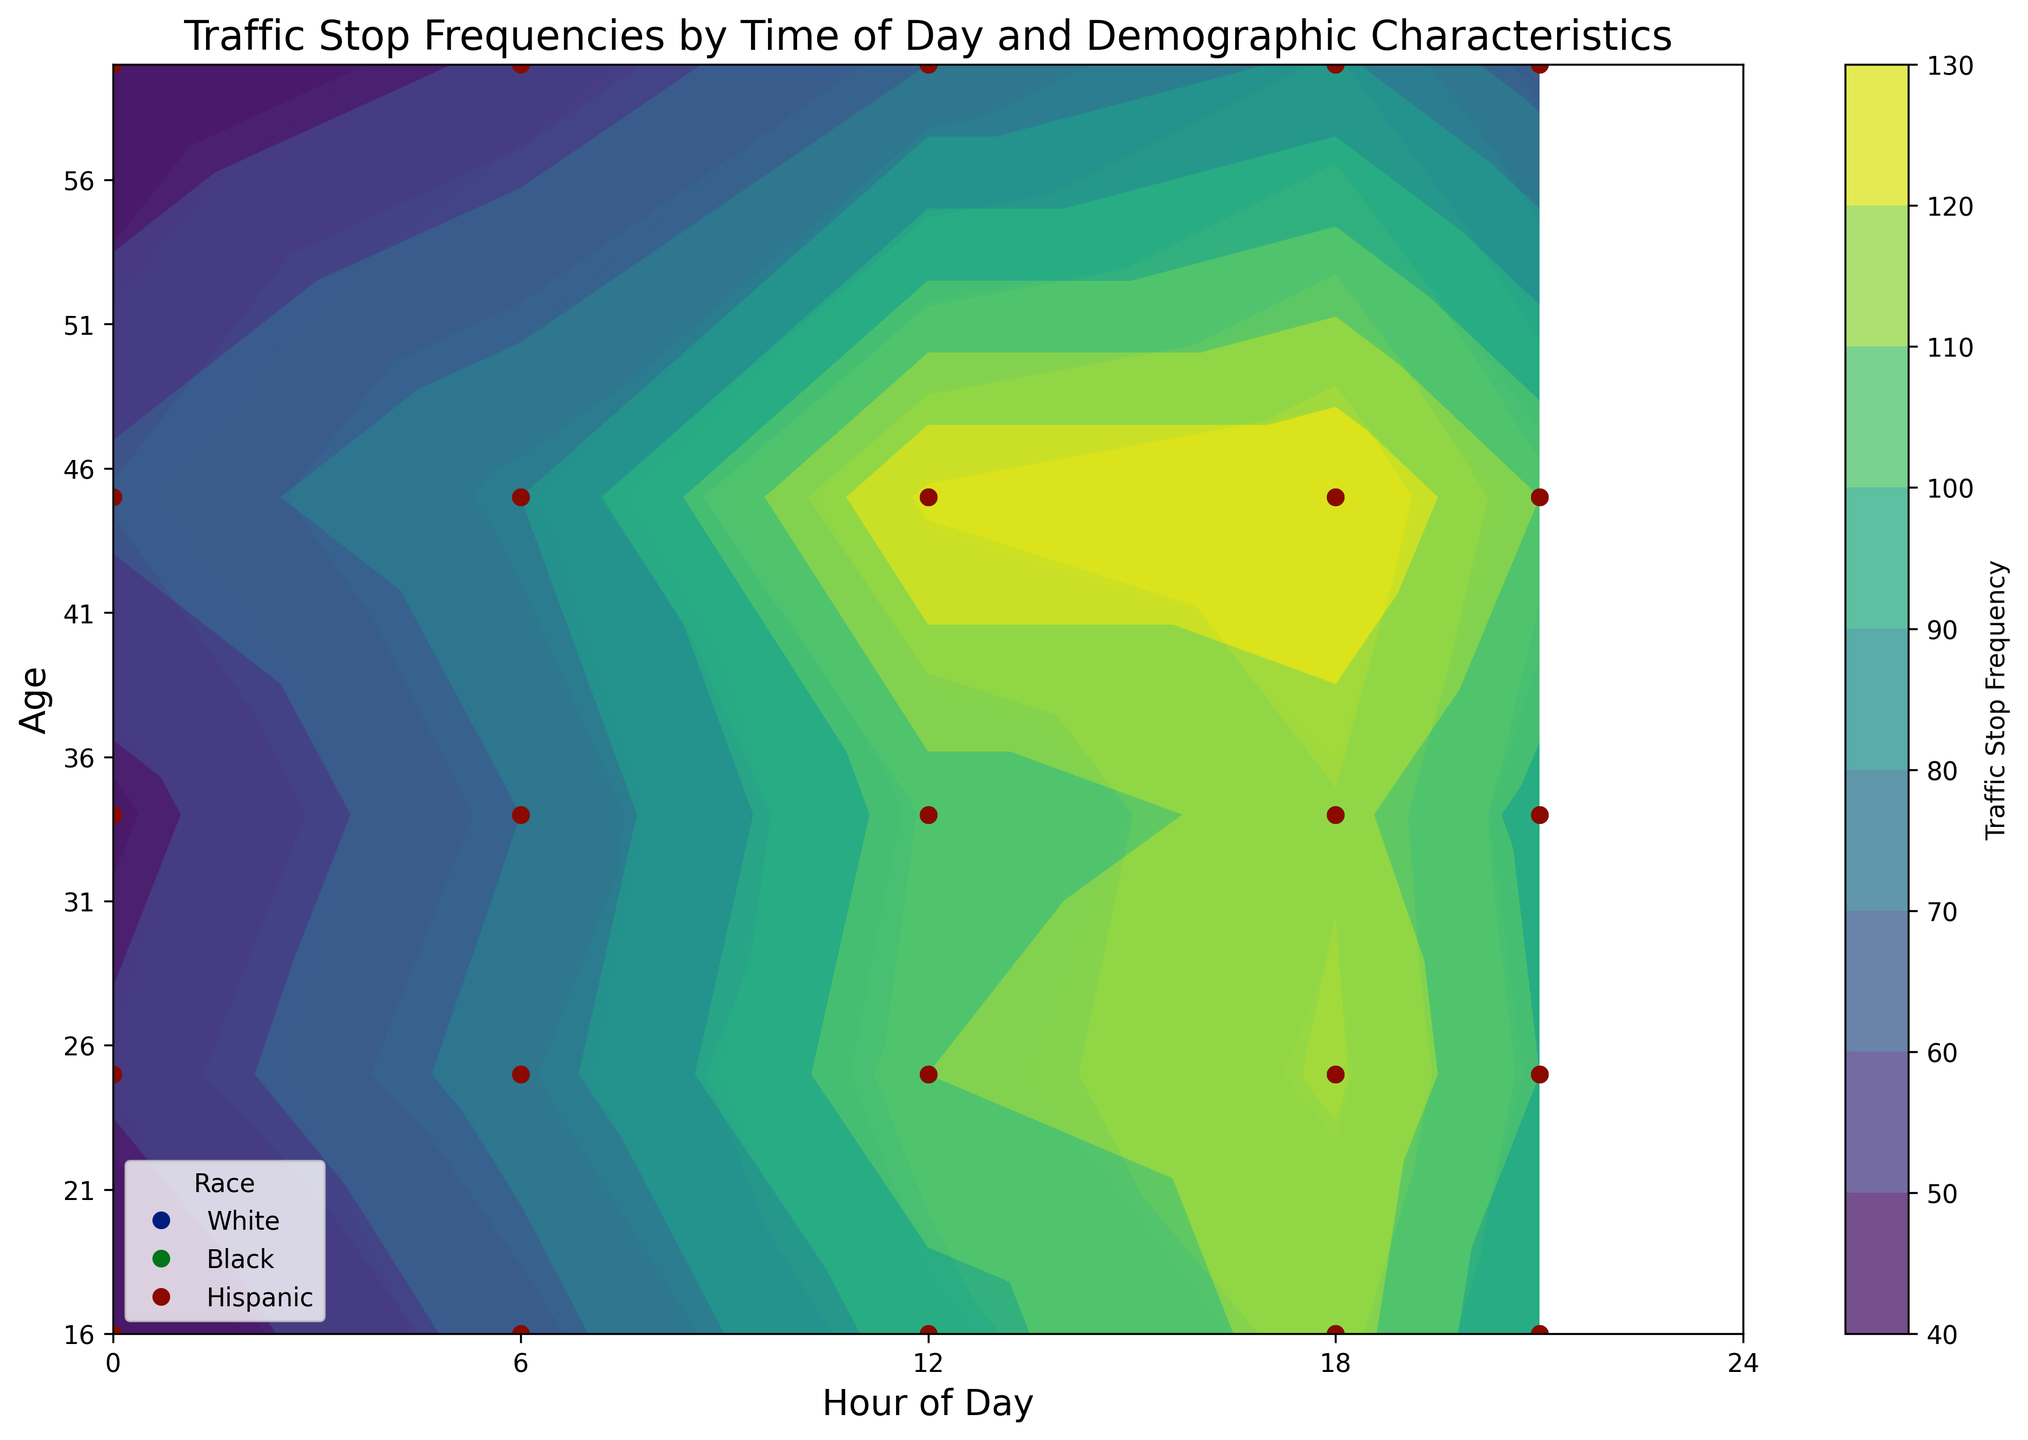What time of day shows the highest traffic stop frequency for 16-year-old Hispanic drivers? To find the highest traffic stop frequency for 16-year-old Hispanic drivers, look for the maximum frequency in the corresponding line and color for Hispanics. According to the plot, the highest frequency for 16-year-old Hispanics is at 18:00 hours.
Answer: 18:00 hours How does the traffic stop frequency for Black drivers aged 60 compare between 12:00 and 21:00? Locate the points representing Black drivers aged 60 at 12:00 and 21:00. The traffic stop frequencies are compared between these two times. The frequency for 12:00 is higher than that for 21:00.
Answer: Higher at 12:00 What's the range of traffic stop frequencies observed for White drivers? Identify the highest and lowest frequencies for White drivers across all ages and times. The highest observed frequency is around 160 (at 18:00 for age 45), and the lowest is 47 (at 00:00 for age 60). The range is the difference between these values.
Answer: 160 - 47 = 113 Is there a time of day when Hispanic drivers aged 34 are equally stopped as White drivers aged 34? Check the contour lines for traffic stop frequencies for both Hispanic and White drivers aged 34 across different times. Look for times where both frequencies are similar. According to the plot, there are similar frequencies at 12:00 and 6:00.
Answer: 6:00 and 12:00 What time of day shows the most significant difference between traffic stop frequencies for Black and Hispanic drivers aged 45? Compare the traffic stop frequencies for Black and Hispanic drivers aged 45 across different times of day. Daytime (around 12:00) shows the highest value difference (130 for Hispanics vs. 100 for Blacks).
Answer: 12:00 What is the trend in traffic stop frequency for 25-year-old White drivers from midnight to 21:00? Follow the line for 25-year-old White drivers from 0:00 to 21:00 and observe the changes in frequency. The plot shows an increasing trend from midnight (60) to the peak at 12:00 (130), then slightly decreases by 21:00 (120).
Answer: Increasing, peaking at 12:00, then decreasing At what times do traffic stop frequencies appear to peak for all ages? By examining the contour and peaks across all age lines, the highest peaks for all ages are found generally at 12:00 and 18:00.
Answer: 12:00 and 18:00 What's the overall pattern in stop frequencies for ages from 16 to 34 across all races by time? Assess the contour lines and summarize the changes for ages 16 to 34 across different times. The plot indicates stop frequencies increase from midnight, peak around midday (12:00) to evening (18:00), and then decrease by night (21:00).
Answer: Increase till midday/evening, decrease by night For White drivers aged 34, how does the stop frequency change from 6:00 to 18:00? Trace the contour line for White drivers aged 34. The frequency increases steadily from 6:00 (85) to 18:00 (145).
Answer: Increasing 